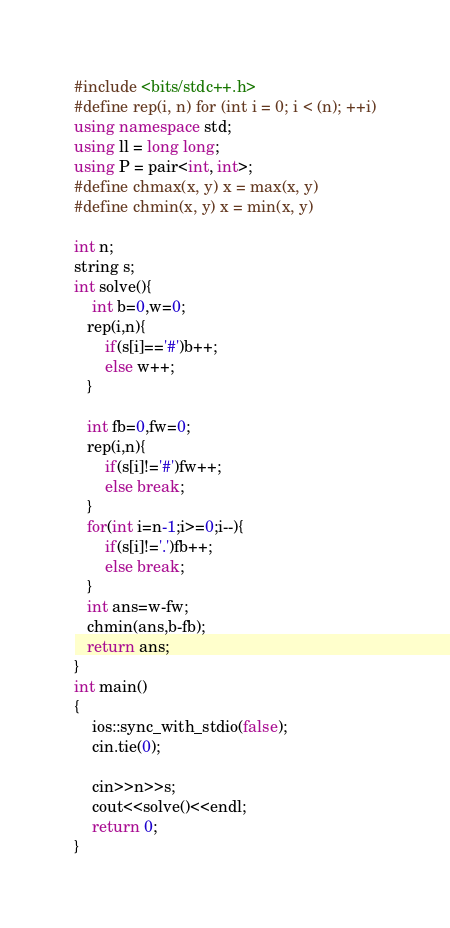<code> <loc_0><loc_0><loc_500><loc_500><_C++_>#include <bits/stdc++.h>
#define rep(i, n) for (int i = 0; i < (n); ++i)
using namespace std;
using ll = long long;
using P = pair<int, int>;
#define chmax(x, y) x = max(x, y)
#define chmin(x, y) x = min(x, y)

int n;
string s;
int solve(){
    int b=0,w=0;
   rep(i,n){
       if(s[i]=='#')b++;
       else w++;
   }

   int fb=0,fw=0;
   rep(i,n){
       if(s[i]!='#')fw++;
       else break;
   }
   for(int i=n-1;i>=0;i--){
       if(s[i]!='.')fb++;
       else break;
   }
   int ans=w-fw;
   chmin(ans,b-fb);
   return ans;
}
int main()
{
    ios::sync_with_stdio(false);
    cin.tie(0);

    cin>>n>>s;
    cout<<solve()<<endl;
    return 0;
}</code> 